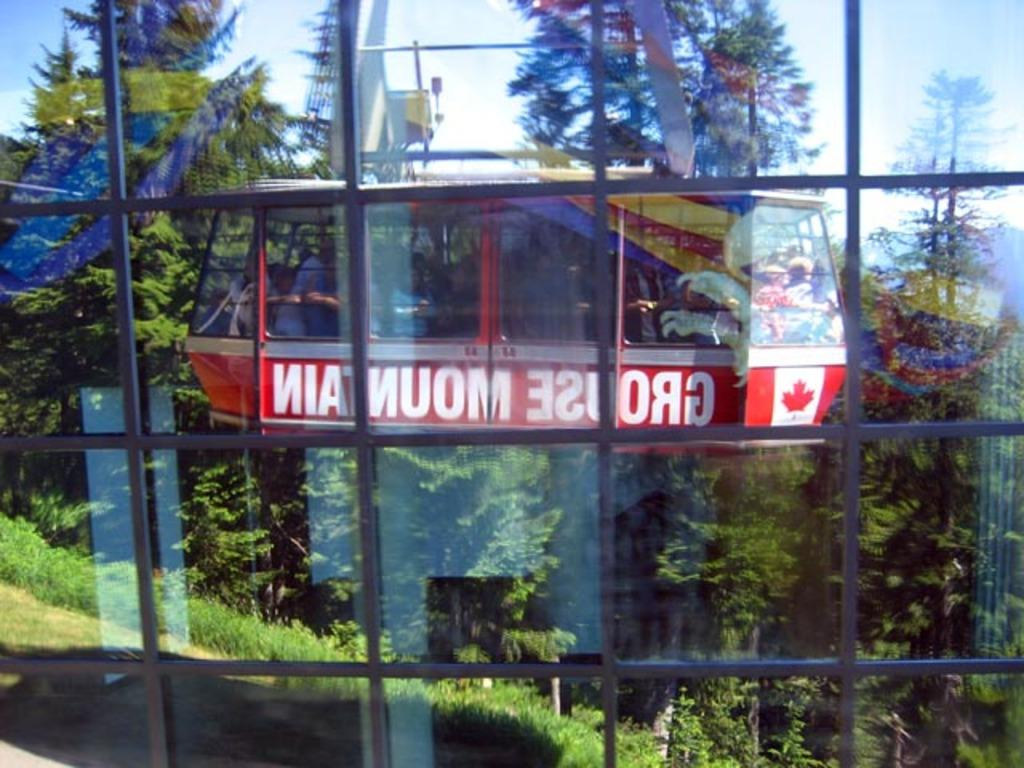Provide a one-sentence caption for the provided image. A reflection of Canadian sky ride looking outwards at a forest. 